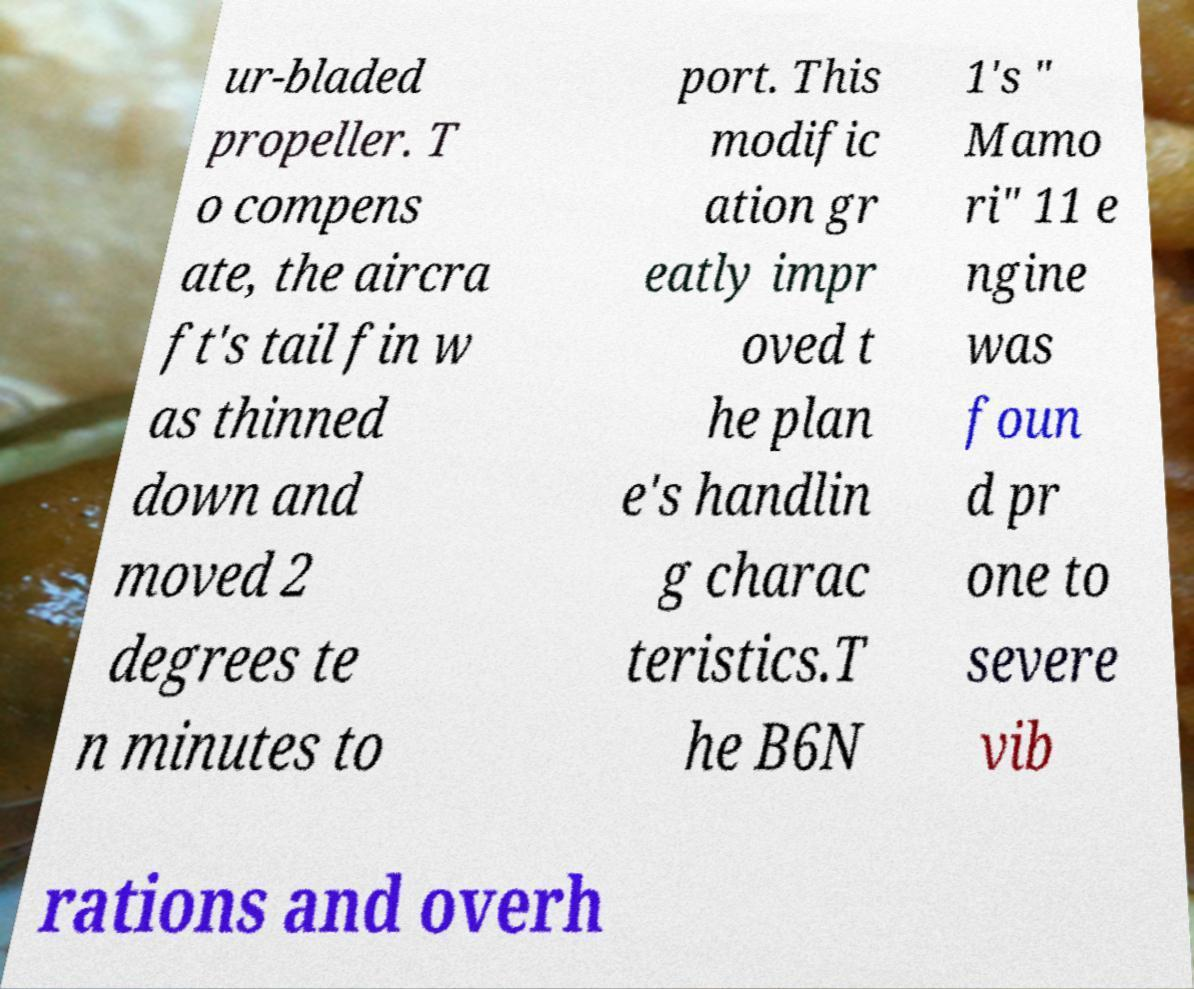Can you accurately transcribe the text from the provided image for me? ur-bladed propeller. T o compens ate, the aircra ft's tail fin w as thinned down and moved 2 degrees te n minutes to port. This modific ation gr eatly impr oved t he plan e's handlin g charac teristics.T he B6N 1's " Mamo ri" 11 e ngine was foun d pr one to severe vib rations and overh 